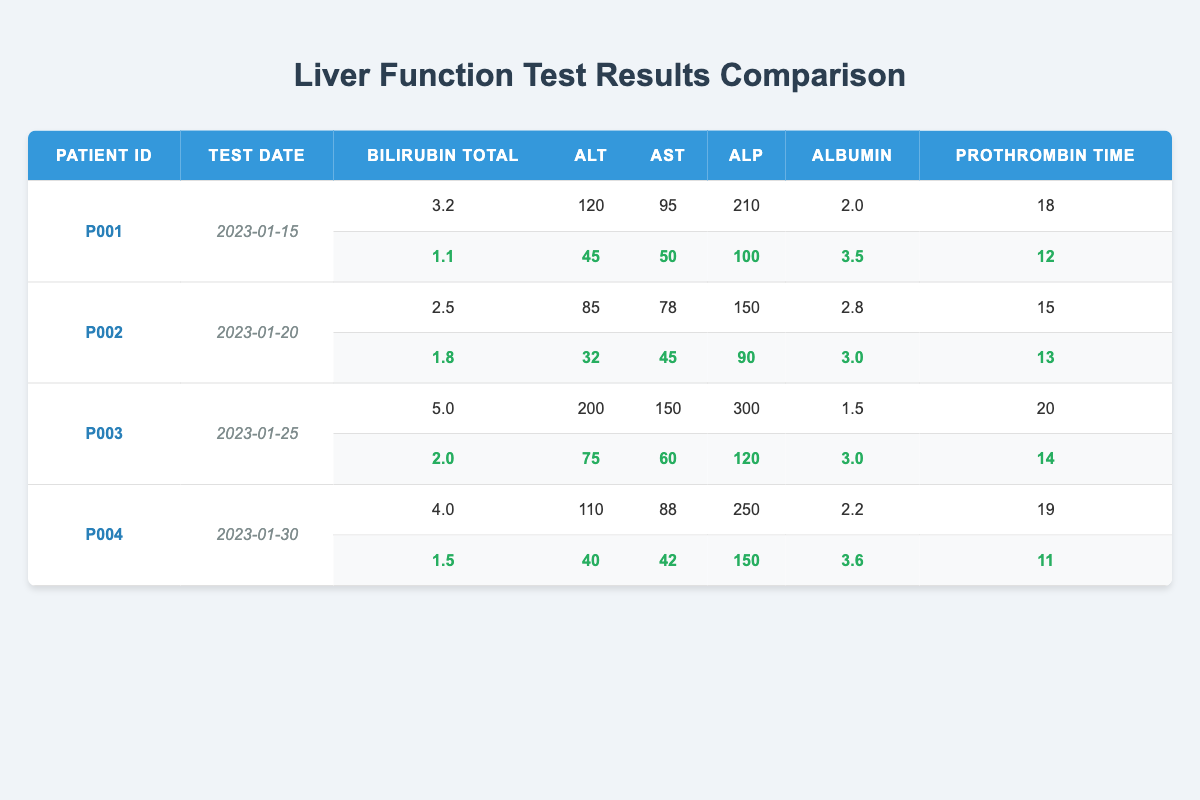What was the total bilirubin level for patient P001 before treatment? By looking at the row for patient P001, the total bilirubin level before treatment is listed as 3.2 mg/dL.
Answer: 3.2 mg/dL What was the alanine aminotransferase (ALT) level for patient P002 after treatment? Referring to patient P002, the ALT level after treatment is 32 U/L.
Answer: 32 U/L Which patient had the highest prothrombin time before treatment? By comparing the prothrombin time values before treatment, patient P003 has the highest value at 20 seconds.
Answer: P003 How much did the albumin level improve for patient P004 after treatment? For patient P004, the albumin level improved from 2.2 g/dL before treatment to 3.6 g/dL after treatment. The change is calculated as 3.6 - 2.2 = 1.4 g/dL.
Answer: 1.4 g/dL What is the average alanine aminotransferase (ALT) level after treatment for all patients? The ALT levels after treatment are 45 (P001), 32 (P002), 75 (P003), and 40 (P004). The total is 45 + 32 + 75 + 40 = 192, and there are 4 patients, so the average is 192 / 4 = 48.
Answer: 48 U/L Did any patient have an alkaline phosphatase (ALP) level greater than 200 before treatment? Checking the ALP levels before treatment, patient P003 had an ALP level of 300, which is indeed greater than 200.
Answer: Yes Which patient's bilirubin level decreased the most after treatment, and by how much? For all patients, we calculate the decrease: P001 (3.2 - 1.1 = 2.1), P002 (2.5 - 1.8 = 0.7), P003 (5.0 - 2.0 = 3.0), and P004 (4.0 - 1.5 = 2.5). The largest decrease is 3.0 for patient P003.
Answer: P003, by 3.0 mg/dL What is the ratio of the alanine aminotransferase (ALT) level before treatment for patient P001 to after treatment? For patient P001, the ALT level before treatment is 120 and after treatment is 45. The ratio is 120 / 45 = 2.67.
Answer: 2.67 Was there any patient who showed an increase in albumin levels after treatment? By evaluating the albumin levels after treatment, all patients show an increase: P001 (from 2.0 to 3.5), P002 (2.8 to 3.0), P003 (1.5 to 3.0), and P004 (2.2 to 3.6). Therefore, the answer is yes.
Answer: Yes What was the overall improvement in prothrombin time for all patients combined? The prothrombin times were: P001 (18 - 12 = 6), P002 (15 - 13 = 2), P003 (20 - 14 = 6), and P004 (19 - 11 = 8). Summing these improvements gives 6 + 2 + 6 + 8 = 22 seconds.
Answer: 22 seconds 